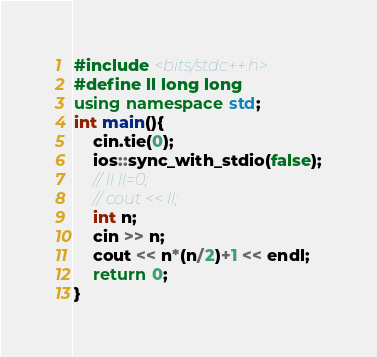<code> <loc_0><loc_0><loc_500><loc_500><_C++_>#include <bits/stdc++.h>
#define ll long long
using namespace std;
int main(){
    cin.tie(0);
   	ios::sync_with_stdio(false);
    // ll ll=0;
    // cout << ll;
    int n;
    cin >> n;
    cout << n*(n/2)+1 << endl;
    return 0;
}
</code> 